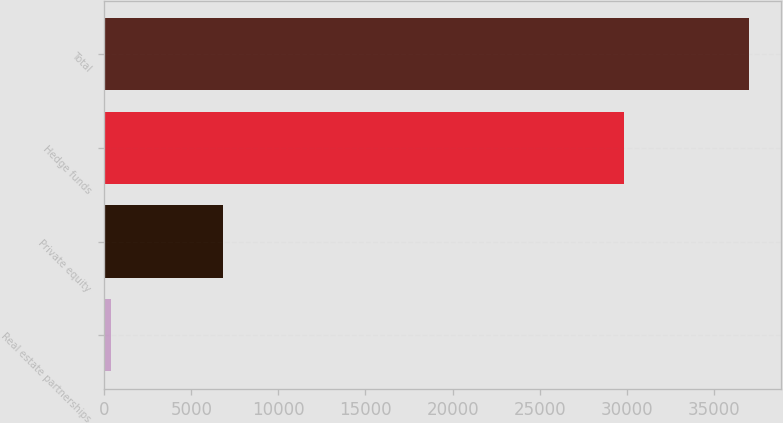Convert chart to OTSL. <chart><loc_0><loc_0><loc_500><loc_500><bar_chart><fcel>Real estate partnerships<fcel>Private equity<fcel>Hedge funds<fcel>Total<nl><fcel>365<fcel>6821<fcel>29839<fcel>37025<nl></chart> 